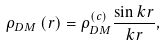Convert formula to latex. <formula><loc_0><loc_0><loc_500><loc_500>\rho _ { D M } \left ( r \right ) = \rho _ { D M } ^ { ( c ) } \frac { \sin k r } { k r } ,</formula> 